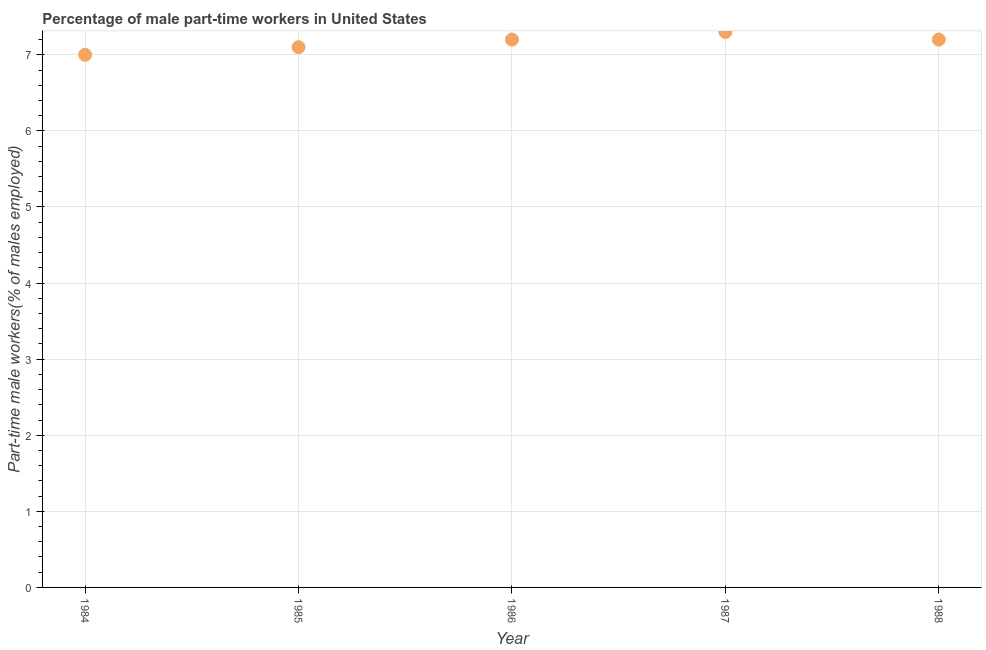What is the percentage of part-time male workers in 1987?
Your answer should be compact. 7.3. Across all years, what is the maximum percentage of part-time male workers?
Provide a succinct answer. 7.3. Across all years, what is the minimum percentage of part-time male workers?
Your response must be concise. 7. In which year was the percentage of part-time male workers maximum?
Make the answer very short. 1987. In which year was the percentage of part-time male workers minimum?
Make the answer very short. 1984. What is the sum of the percentage of part-time male workers?
Offer a terse response. 35.8. What is the difference between the percentage of part-time male workers in 1984 and 1987?
Make the answer very short. -0.3. What is the average percentage of part-time male workers per year?
Offer a very short reply. 7.16. What is the median percentage of part-time male workers?
Give a very brief answer. 7.2. Do a majority of the years between 1986 and 1988 (inclusive) have percentage of part-time male workers greater than 0.2 %?
Ensure brevity in your answer.  Yes. What is the ratio of the percentage of part-time male workers in 1984 to that in 1987?
Your answer should be compact. 0.96. Is the percentage of part-time male workers in 1986 less than that in 1987?
Offer a terse response. Yes. Is the difference between the percentage of part-time male workers in 1986 and 1987 greater than the difference between any two years?
Your answer should be very brief. No. What is the difference between the highest and the second highest percentage of part-time male workers?
Keep it short and to the point. 0.1. Is the sum of the percentage of part-time male workers in 1985 and 1988 greater than the maximum percentage of part-time male workers across all years?
Make the answer very short. Yes. What is the difference between the highest and the lowest percentage of part-time male workers?
Provide a short and direct response. 0.3. Are the values on the major ticks of Y-axis written in scientific E-notation?
Provide a short and direct response. No. What is the title of the graph?
Provide a short and direct response. Percentage of male part-time workers in United States. What is the label or title of the Y-axis?
Offer a terse response. Part-time male workers(% of males employed). What is the Part-time male workers(% of males employed) in 1984?
Provide a short and direct response. 7. What is the Part-time male workers(% of males employed) in 1985?
Provide a short and direct response. 7.1. What is the Part-time male workers(% of males employed) in 1986?
Ensure brevity in your answer.  7.2. What is the Part-time male workers(% of males employed) in 1987?
Provide a short and direct response. 7.3. What is the Part-time male workers(% of males employed) in 1988?
Make the answer very short. 7.2. What is the difference between the Part-time male workers(% of males employed) in 1985 and 1988?
Your answer should be compact. -0.1. What is the difference between the Part-time male workers(% of males employed) in 1986 and 1987?
Keep it short and to the point. -0.1. What is the difference between the Part-time male workers(% of males employed) in 1986 and 1988?
Keep it short and to the point. 0. What is the difference between the Part-time male workers(% of males employed) in 1987 and 1988?
Ensure brevity in your answer.  0.1. What is the ratio of the Part-time male workers(% of males employed) in 1984 to that in 1986?
Your response must be concise. 0.97. What is the ratio of the Part-time male workers(% of males employed) in 1984 to that in 1987?
Provide a succinct answer. 0.96. What is the ratio of the Part-time male workers(% of males employed) in 1984 to that in 1988?
Provide a short and direct response. 0.97. What is the ratio of the Part-time male workers(% of males employed) in 1985 to that in 1987?
Your answer should be compact. 0.97. What is the ratio of the Part-time male workers(% of males employed) in 1985 to that in 1988?
Give a very brief answer. 0.99. What is the ratio of the Part-time male workers(% of males employed) in 1987 to that in 1988?
Ensure brevity in your answer.  1.01. 